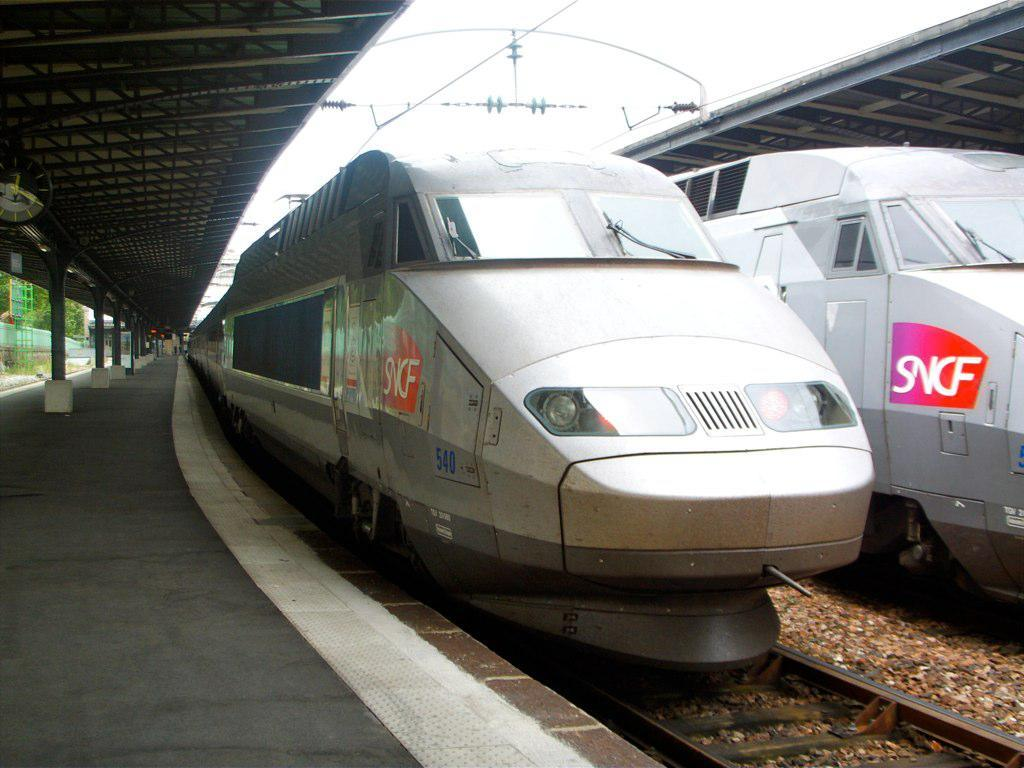<image>
Share a concise interpretation of the image provided. An SNCF train at the station waiting for passengers. 